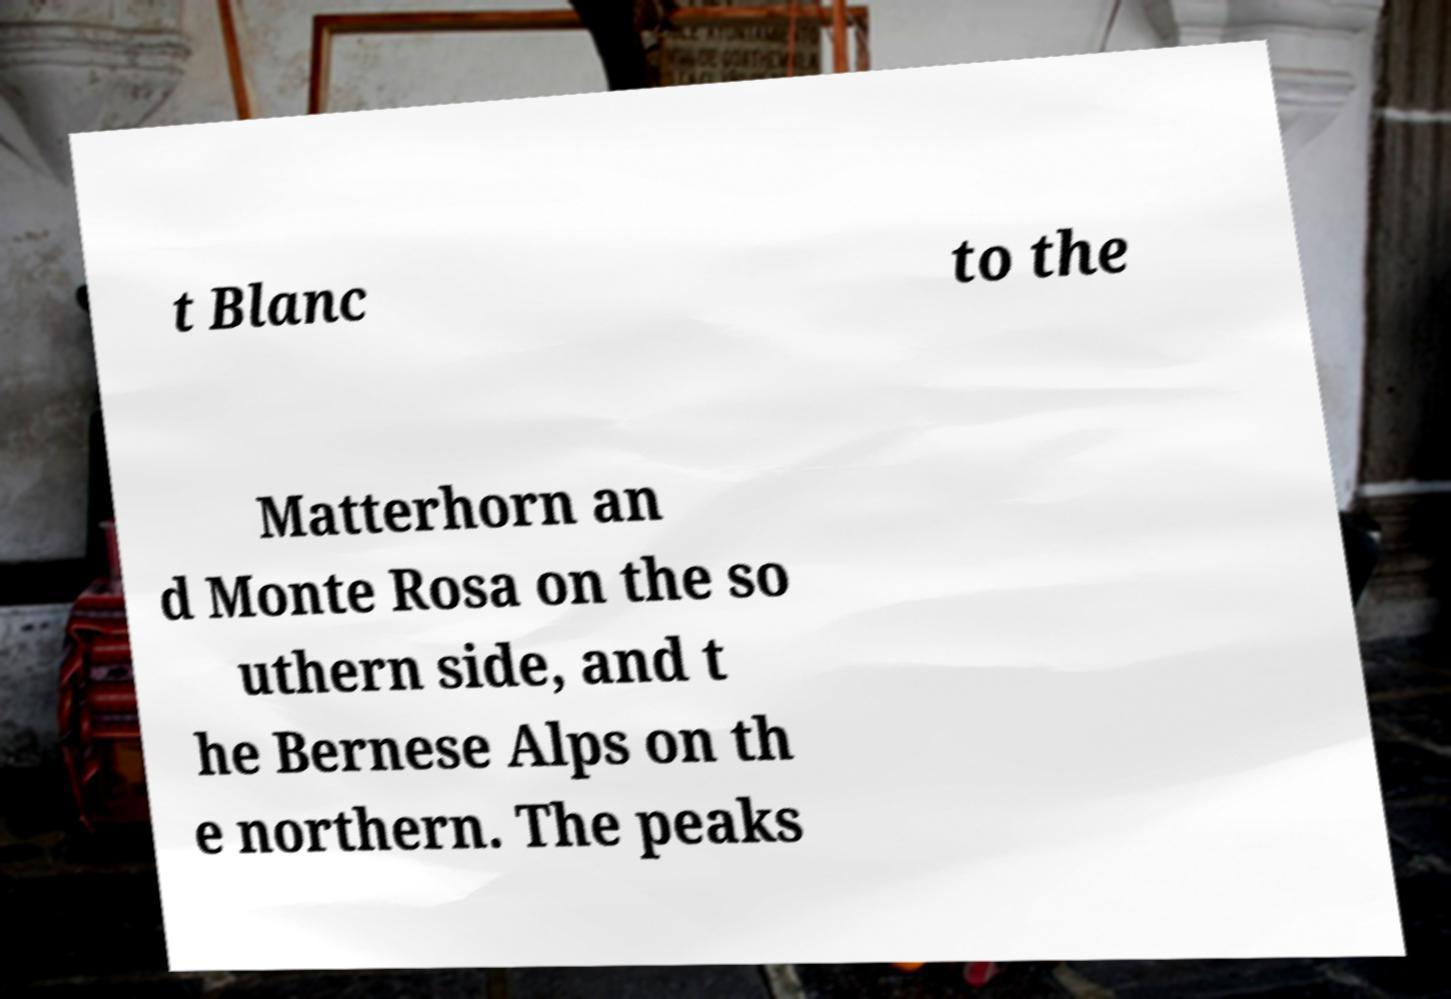Please read and relay the text visible in this image. What does it say? t Blanc to the Matterhorn an d Monte Rosa on the so uthern side, and t he Bernese Alps on th e northern. The peaks 